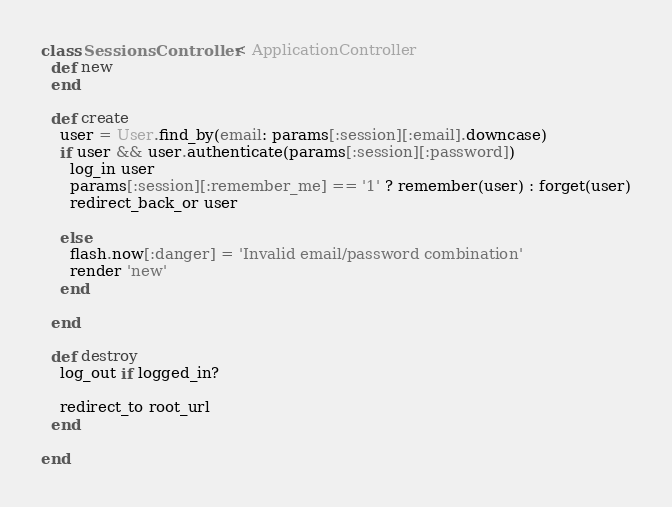<code> <loc_0><loc_0><loc_500><loc_500><_Ruby_>class SessionsController < ApplicationController
  def new
  end

  def create
    user = User.find_by(email: params[:session][:email].downcase)
    if user && user.authenticate(params[:session][:password])
      log_in user
      params[:session][:remember_me] == '1' ? remember(user) : forget(user)
      redirect_back_or user
      
    else
      flash.now[:danger] = 'Invalid email/password combination'
      render 'new'
    end

  end

  def destroy
    log_out if logged_in?

    redirect_to root_url
  end
    
end
</code> 